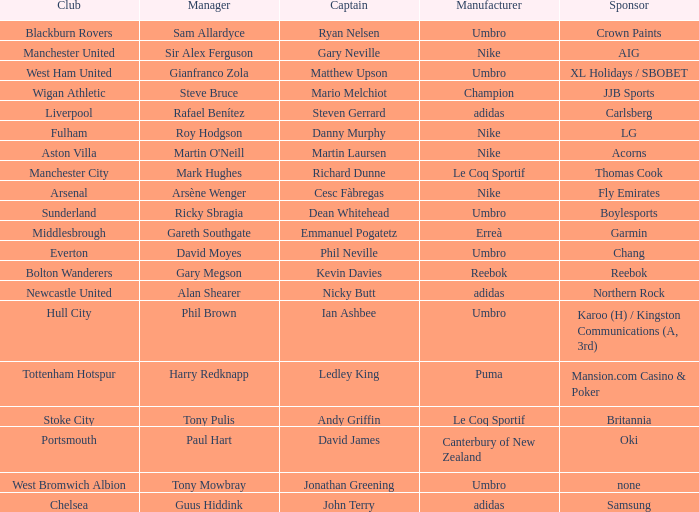What Premier League Manager has an Adidas sponsor and a Newcastle United club? Alan Shearer. 